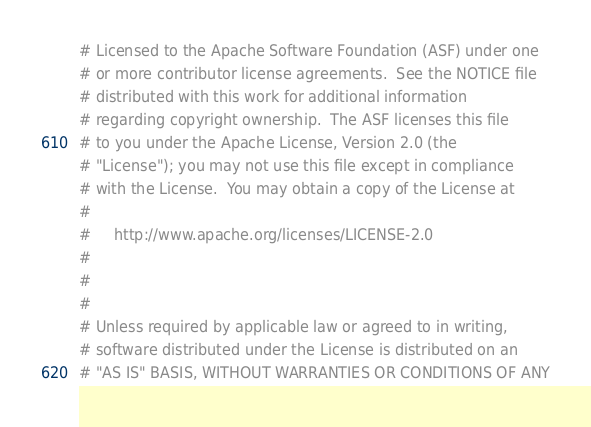Convert code to text. <code><loc_0><loc_0><loc_500><loc_500><_Python_># Licensed to the Apache Software Foundation (ASF) under one
# or more contributor license agreements.  See the NOTICE file
# distributed with this work for additional information
# regarding copyright ownership.  The ASF licenses this file
# to you under the Apache License, Version 2.0 (the
# "License"); you may not use this file except in compliance
# with the License.  You may obtain a copy of the License at
#
#     http://www.apache.org/licenses/LICENSE-2.0
#
#
#
# Unless required by applicable law or agreed to in writing,
# software distributed under the License is distributed on an
# "AS IS" BASIS, WITHOUT WARRANTIES OR CONDITIONS OF ANY</code> 